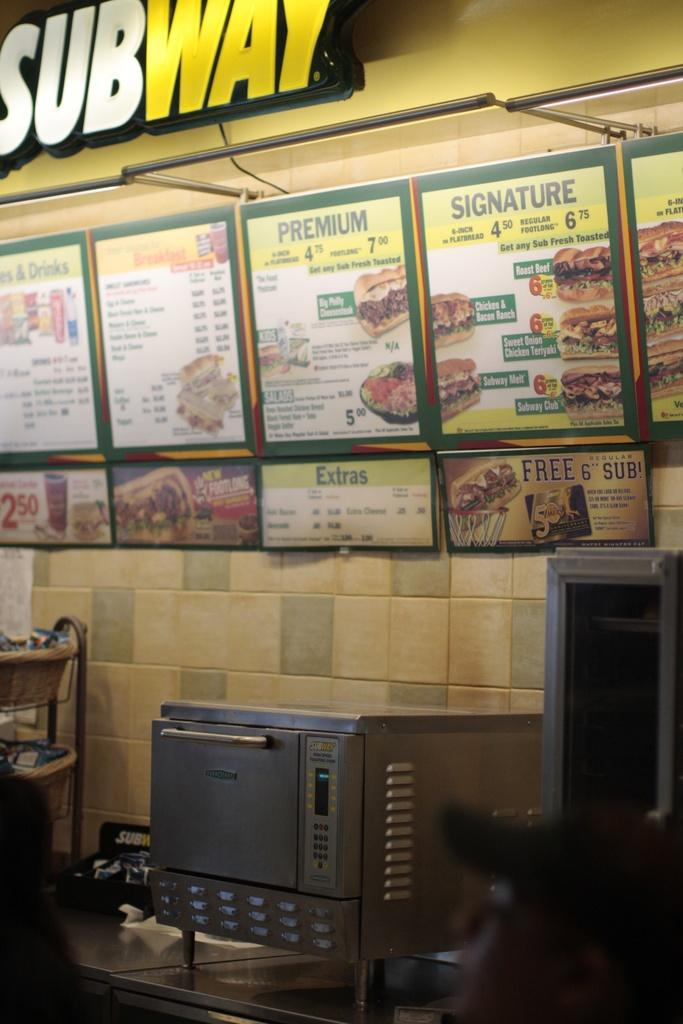What type of appliance is visible in the image? There is an oven in the image. Where is the oven located? The oven is on a table in the image. What can be seen on the wall in the image? There are photo frames on the wall. What is the banner in the image promoting? The banner in the image says "Subway". Can you describe the beetle crawling on the banner in the image? There is no beetle present in the image; the focus is on the oven, photo frames, and banner. What type of muscle is visible in the image? There are no muscles visible in the image; it features an oven, photo frames, and a banner. 